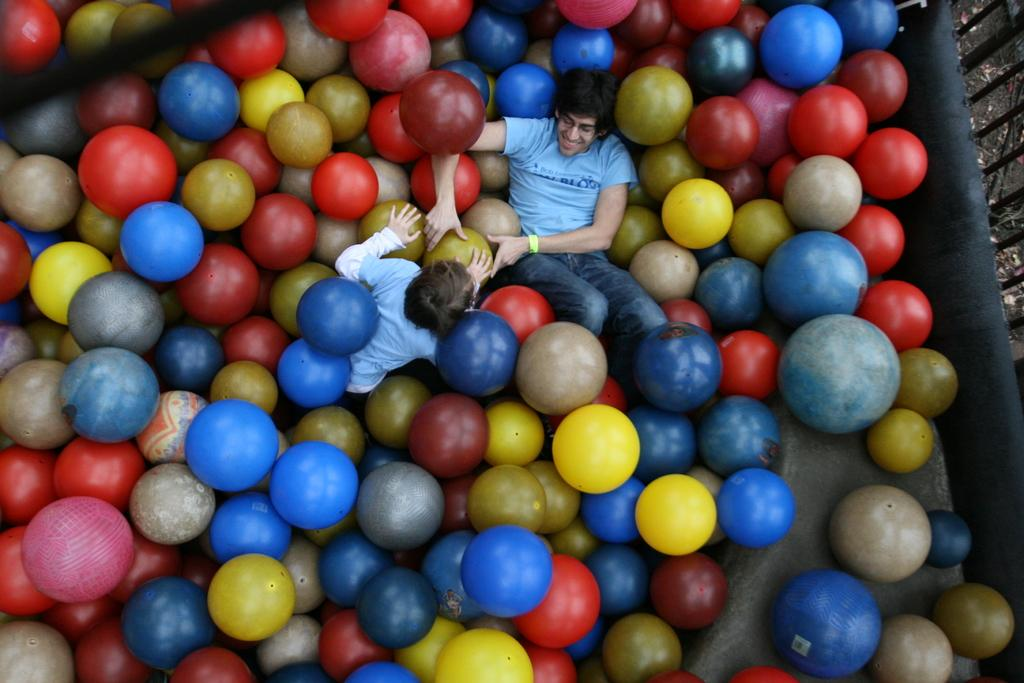How many people are present in the image? There are two people in the image. What objects can be seen in the image besides the people? There are balls in the image. What type of barrier is visible in the image? There is a fence in the image. What type of copper material can be seen in the image? There is no copper material present in the image. What type of waste is visible in the image? There is no waste visible in the image. 